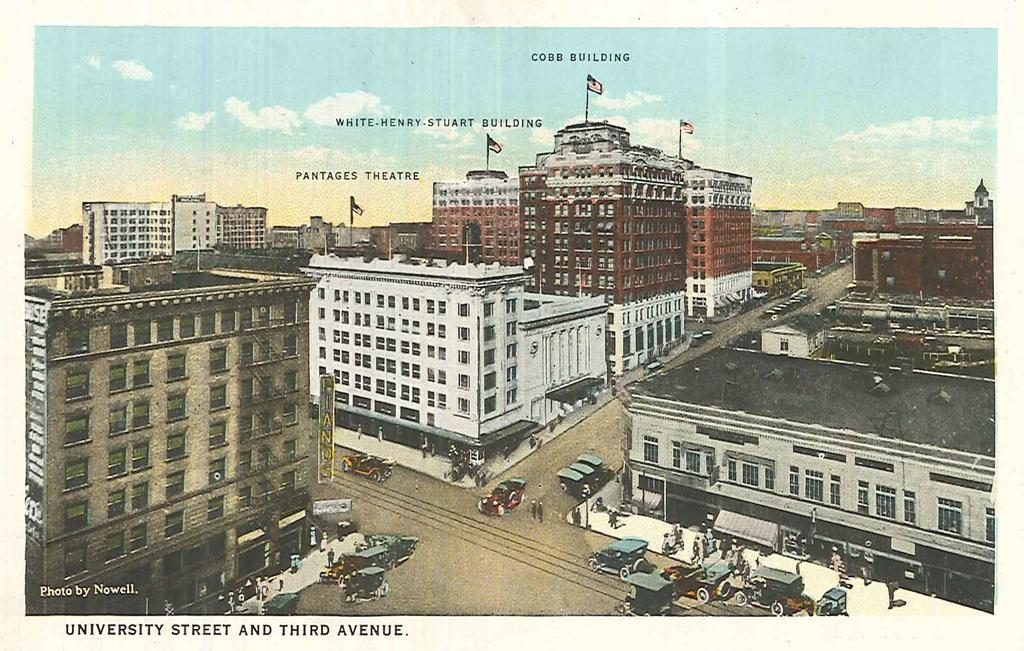What is the main subject of the poster in the image? The poster contains images of buildings and vehicles on a road. Are there any living creatures depicted on the poster? No, there are no living creatures depicted on the poster. What else can be found on the poster besides images? There is text on the poster. What type of bird can be seen flying over the buildings on the poster? There are no birds depicted on the poster; it only contains images of buildings and vehicles on a road. Can you tell me how many pigs are present in the poster? There are no pigs depicted in the poster. 